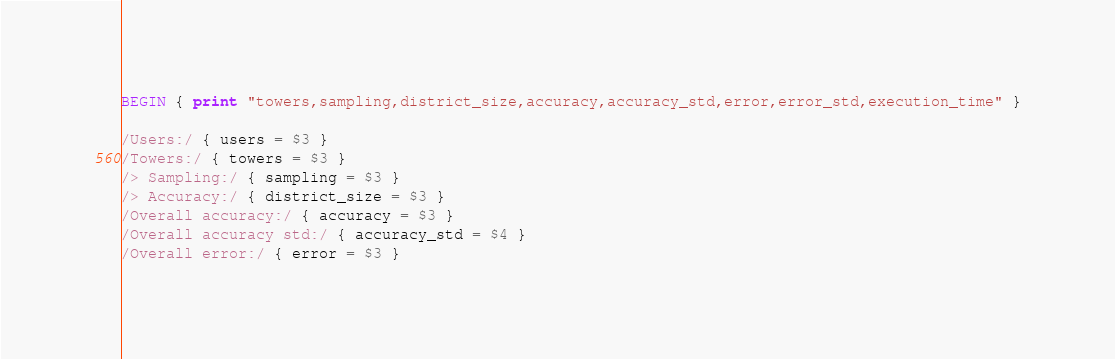<code> <loc_0><loc_0><loc_500><loc_500><_Awk_>BEGIN { print "towers,sampling,district_size,accuracy,accuracy_std,error,error_std,execution_time" }

/Users:/ { users = $3 }
/Towers:/ { towers = $3 }
/> Sampling:/ { sampling = $3 }
/> Accuracy:/ { district_size = $3 }
/Overall accuracy:/ { accuracy = $3 }
/Overall accuracy std:/ { accuracy_std = $4 }
/Overall error:/ { error = $3 }</code> 